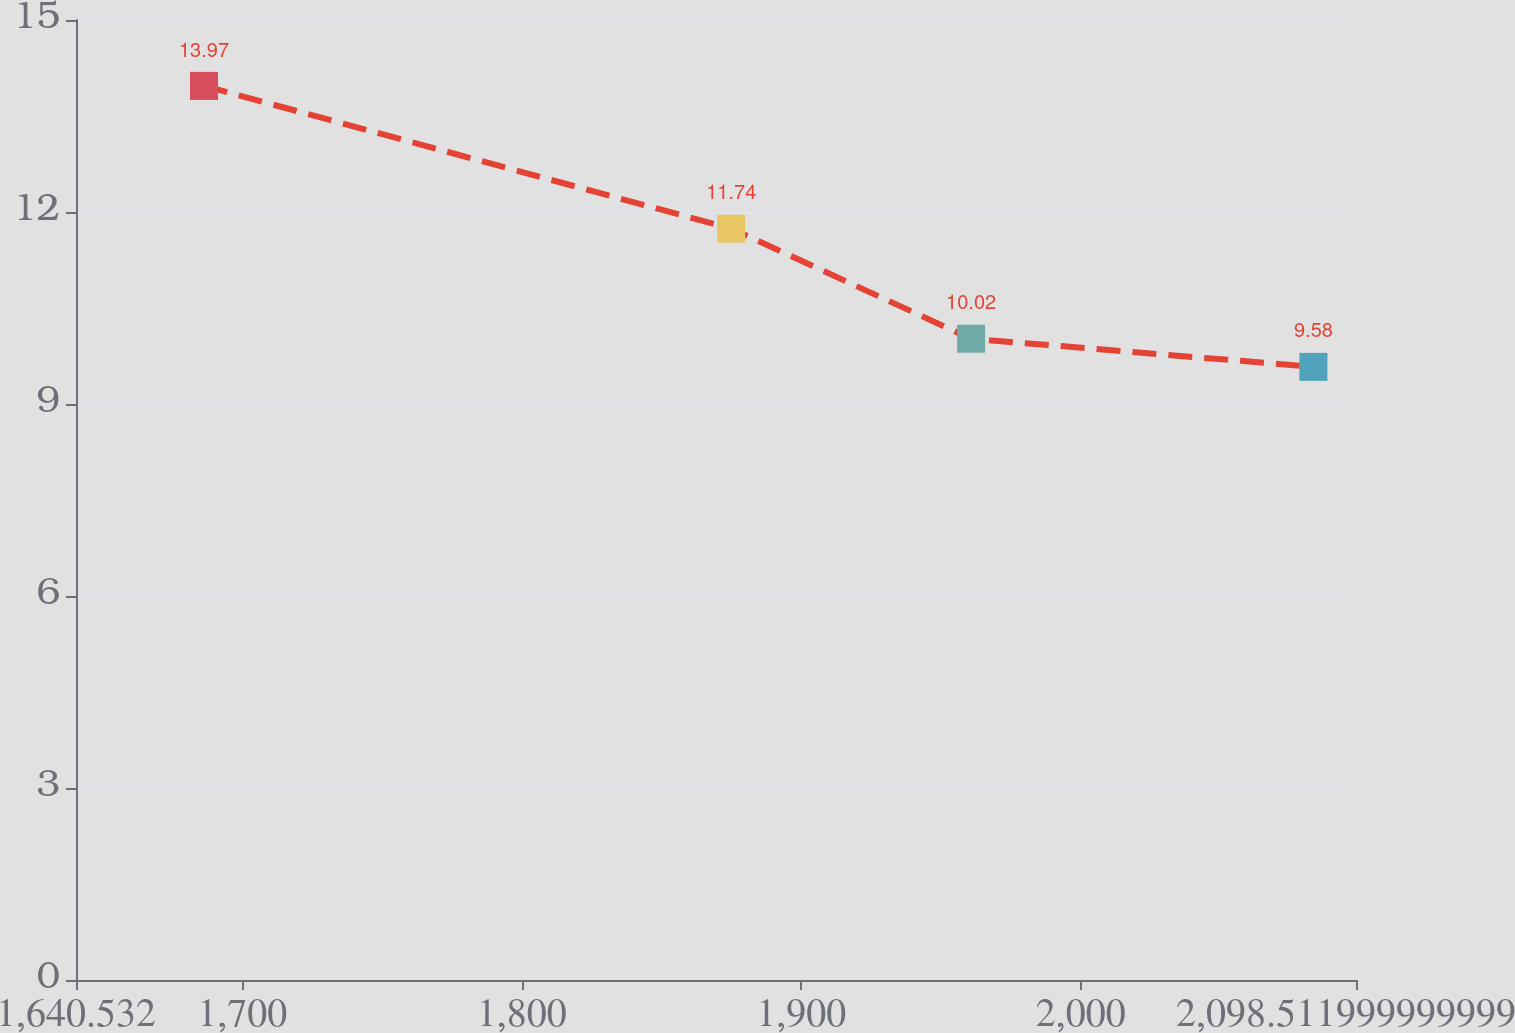<chart> <loc_0><loc_0><loc_500><loc_500><line_chart><ecel><fcel>Total<nl><fcel>1686.33<fcel>13.97<nl><fcel>1874.97<fcel>11.74<nl><fcel>1960.8<fcel>10.02<nl><fcel>2083.28<fcel>9.58<nl><fcel>2144.31<fcel>12.18<nl></chart> 